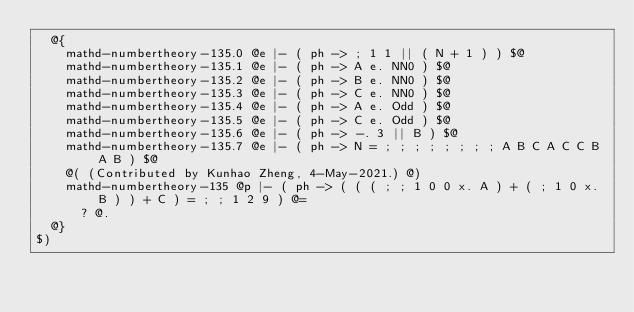Convert code to text. <code><loc_0><loc_0><loc_500><loc_500><_ObjectiveC_>  @{
    mathd-numbertheory-135.0 @e |- ( ph -> ; 1 1 || ( N + 1 ) ) $@
    mathd-numbertheory-135.1 @e |- ( ph -> A e. NN0 ) $@
    mathd-numbertheory-135.2 @e |- ( ph -> B e. NN0 ) $@
    mathd-numbertheory-135.3 @e |- ( ph -> C e. NN0 ) $@
    mathd-numbertheory-135.4 @e |- ( ph -> A e. Odd ) $@
    mathd-numbertheory-135.5 @e |- ( ph -> C e. Odd ) $@
    mathd-numbertheory-135.6 @e |- ( ph -> -. 3 || B ) $@
    mathd-numbertheory-135.7 @e |- ( ph -> N = ; ; ; ; ; ; ; ; A B C A C C B A B ) $@
    @( (Contributed by Kunhao Zheng, 4-May-2021.) @)
    mathd-numbertheory-135 @p |- ( ph -> ( ( ( ; ; 1 0 0 x. A ) + ( ; 1 0 x. B ) ) + C ) = ; ; 1 2 9 ) @=
      ? @.
  @}
$)
</code> 